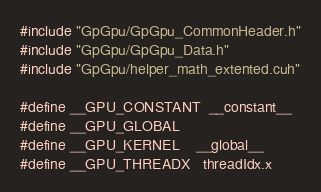Convert code to text. <code><loc_0><loc_0><loc_500><loc_500><_Cuda_>#include "GpGpu/GpGpu_CommonHeader.h"
#include "GpGpu/GpGpu_Data.h"
#include "GpGpu/helper_math_extented.cuh"

#define __GPU_CONSTANT  __constant__
#define __GPU_GLOBAL
#define __GPU_KERNEL    __global__
#define __GPU_THREADX   threadIdx.x
</code> 